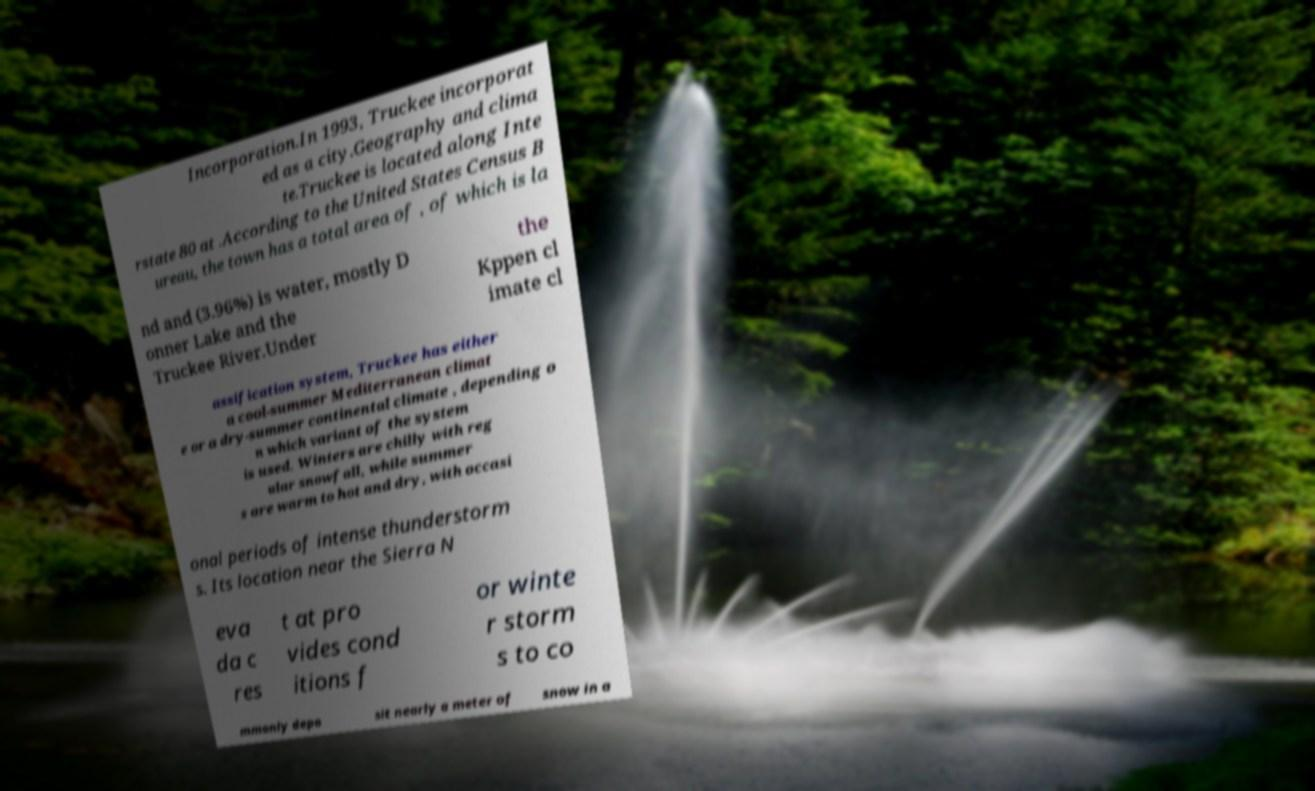Can you accurately transcribe the text from the provided image for me? Incorporation.In 1993, Truckee incorporat ed as a city.Geography and clima te.Truckee is located along Inte rstate 80 at .According to the United States Census B ureau, the town has a total area of , of which is la nd and (3.96%) is water, mostly D onner Lake and the Truckee River.Under the Kppen cl imate cl assification system, Truckee has either a cool-summer Mediterranean climat e or a dry-summer continental climate , depending o n which variant of the system is used. Winters are chilly with reg ular snowfall, while summer s are warm to hot and dry, with occasi onal periods of intense thunderstorm s. Its location near the Sierra N eva da c res t at pro vides cond itions f or winte r storm s to co mmonly depo sit nearly a meter of snow in a 